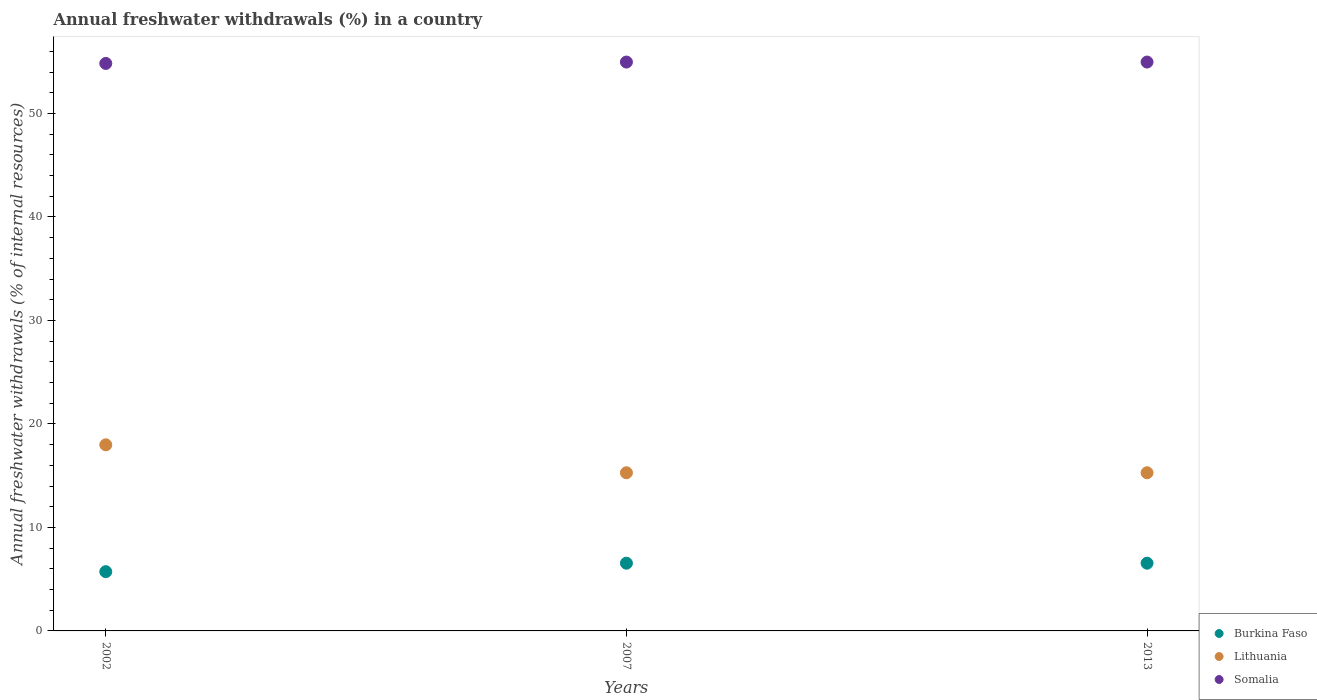Is the number of dotlines equal to the number of legend labels?
Offer a very short reply. Yes. What is the percentage of annual freshwater withdrawals in Lithuania in 2013?
Offer a very short reply. 15.28. Across all years, what is the maximum percentage of annual freshwater withdrawals in Burkina Faso?
Your response must be concise. 6.54. Across all years, what is the minimum percentage of annual freshwater withdrawals in Lithuania?
Your response must be concise. 15.28. In which year was the percentage of annual freshwater withdrawals in Somalia minimum?
Provide a succinct answer. 2002. What is the total percentage of annual freshwater withdrawals in Burkina Faso in the graph?
Keep it short and to the point. 18.81. What is the difference between the percentage of annual freshwater withdrawals in Burkina Faso in 2002 and that in 2007?
Provide a succinct answer. -0.82. What is the difference between the percentage of annual freshwater withdrawals in Burkina Faso in 2002 and the percentage of annual freshwater withdrawals in Somalia in 2007?
Give a very brief answer. -49.24. What is the average percentage of annual freshwater withdrawals in Somalia per year?
Provide a succinct answer. 54.92. In the year 2007, what is the difference between the percentage of annual freshwater withdrawals in Burkina Faso and percentage of annual freshwater withdrawals in Lithuania?
Provide a short and direct response. -8.74. What is the ratio of the percentage of annual freshwater withdrawals in Burkina Faso in 2002 to that in 2013?
Your answer should be very brief. 0.87. Is the difference between the percentage of annual freshwater withdrawals in Burkina Faso in 2007 and 2013 greater than the difference between the percentage of annual freshwater withdrawals in Lithuania in 2007 and 2013?
Provide a short and direct response. No. What is the difference between the highest and the second highest percentage of annual freshwater withdrawals in Lithuania?
Provide a succinct answer. 2.7. What is the difference between the highest and the lowest percentage of annual freshwater withdrawals in Burkina Faso?
Your response must be concise. 0.82. Is it the case that in every year, the sum of the percentage of annual freshwater withdrawals in Somalia and percentage of annual freshwater withdrawals in Burkina Faso  is greater than the percentage of annual freshwater withdrawals in Lithuania?
Keep it short and to the point. Yes. Does the percentage of annual freshwater withdrawals in Lithuania monotonically increase over the years?
Your response must be concise. No. Is the percentage of annual freshwater withdrawals in Burkina Faso strictly less than the percentage of annual freshwater withdrawals in Somalia over the years?
Your answer should be very brief. Yes. Does the graph contain grids?
Give a very brief answer. No. How many legend labels are there?
Your answer should be very brief. 3. What is the title of the graph?
Ensure brevity in your answer.  Annual freshwater withdrawals (%) in a country. Does "Cayman Islands" appear as one of the legend labels in the graph?
Offer a very short reply. No. What is the label or title of the Y-axis?
Keep it short and to the point. Annual freshwater withdrawals (% of internal resources). What is the Annual freshwater withdrawals (% of internal resources) of Burkina Faso in 2002?
Give a very brief answer. 5.73. What is the Annual freshwater withdrawals (% of internal resources) in Lithuania in 2002?
Your answer should be very brief. 17.98. What is the Annual freshwater withdrawals (% of internal resources) of Somalia in 2002?
Your response must be concise. 54.83. What is the Annual freshwater withdrawals (% of internal resources) in Burkina Faso in 2007?
Provide a succinct answer. 6.54. What is the Annual freshwater withdrawals (% of internal resources) in Lithuania in 2007?
Make the answer very short. 15.28. What is the Annual freshwater withdrawals (% of internal resources) of Somalia in 2007?
Make the answer very short. 54.97. What is the Annual freshwater withdrawals (% of internal resources) in Burkina Faso in 2013?
Offer a very short reply. 6.54. What is the Annual freshwater withdrawals (% of internal resources) of Lithuania in 2013?
Make the answer very short. 15.28. What is the Annual freshwater withdrawals (% of internal resources) of Somalia in 2013?
Your answer should be compact. 54.97. Across all years, what is the maximum Annual freshwater withdrawals (% of internal resources) in Burkina Faso?
Your response must be concise. 6.54. Across all years, what is the maximum Annual freshwater withdrawals (% of internal resources) of Lithuania?
Your response must be concise. 17.98. Across all years, what is the maximum Annual freshwater withdrawals (% of internal resources) of Somalia?
Make the answer very short. 54.97. Across all years, what is the minimum Annual freshwater withdrawals (% of internal resources) in Burkina Faso?
Give a very brief answer. 5.73. Across all years, what is the minimum Annual freshwater withdrawals (% of internal resources) in Lithuania?
Ensure brevity in your answer.  15.28. Across all years, what is the minimum Annual freshwater withdrawals (% of internal resources) in Somalia?
Offer a terse response. 54.83. What is the total Annual freshwater withdrawals (% of internal resources) in Burkina Faso in the graph?
Give a very brief answer. 18.81. What is the total Annual freshwater withdrawals (% of internal resources) in Lithuania in the graph?
Offer a terse response. 48.55. What is the total Annual freshwater withdrawals (% of internal resources) of Somalia in the graph?
Make the answer very short. 164.77. What is the difference between the Annual freshwater withdrawals (% of internal resources) of Burkina Faso in 2002 and that in 2007?
Offer a terse response. -0.82. What is the difference between the Annual freshwater withdrawals (% of internal resources) of Lithuania in 2002 and that in 2007?
Your answer should be very brief. 2.7. What is the difference between the Annual freshwater withdrawals (% of internal resources) in Somalia in 2002 and that in 2007?
Offer a terse response. -0.13. What is the difference between the Annual freshwater withdrawals (% of internal resources) of Burkina Faso in 2002 and that in 2013?
Offer a very short reply. -0.82. What is the difference between the Annual freshwater withdrawals (% of internal resources) in Lithuania in 2002 and that in 2013?
Ensure brevity in your answer.  2.7. What is the difference between the Annual freshwater withdrawals (% of internal resources) in Somalia in 2002 and that in 2013?
Make the answer very short. -0.13. What is the difference between the Annual freshwater withdrawals (% of internal resources) in Burkina Faso in 2007 and that in 2013?
Provide a succinct answer. 0. What is the difference between the Annual freshwater withdrawals (% of internal resources) of Burkina Faso in 2002 and the Annual freshwater withdrawals (% of internal resources) of Lithuania in 2007?
Ensure brevity in your answer.  -9.56. What is the difference between the Annual freshwater withdrawals (% of internal resources) of Burkina Faso in 2002 and the Annual freshwater withdrawals (% of internal resources) of Somalia in 2007?
Offer a very short reply. -49.24. What is the difference between the Annual freshwater withdrawals (% of internal resources) of Lithuania in 2002 and the Annual freshwater withdrawals (% of internal resources) of Somalia in 2007?
Keep it short and to the point. -36.98. What is the difference between the Annual freshwater withdrawals (% of internal resources) in Burkina Faso in 2002 and the Annual freshwater withdrawals (% of internal resources) in Lithuania in 2013?
Your answer should be compact. -9.56. What is the difference between the Annual freshwater withdrawals (% of internal resources) in Burkina Faso in 2002 and the Annual freshwater withdrawals (% of internal resources) in Somalia in 2013?
Your answer should be very brief. -49.24. What is the difference between the Annual freshwater withdrawals (% of internal resources) of Lithuania in 2002 and the Annual freshwater withdrawals (% of internal resources) of Somalia in 2013?
Keep it short and to the point. -36.98. What is the difference between the Annual freshwater withdrawals (% of internal resources) of Burkina Faso in 2007 and the Annual freshwater withdrawals (% of internal resources) of Lithuania in 2013?
Ensure brevity in your answer.  -8.74. What is the difference between the Annual freshwater withdrawals (% of internal resources) in Burkina Faso in 2007 and the Annual freshwater withdrawals (% of internal resources) in Somalia in 2013?
Provide a short and direct response. -48.42. What is the difference between the Annual freshwater withdrawals (% of internal resources) in Lithuania in 2007 and the Annual freshwater withdrawals (% of internal resources) in Somalia in 2013?
Provide a succinct answer. -39.68. What is the average Annual freshwater withdrawals (% of internal resources) of Burkina Faso per year?
Your answer should be very brief. 6.27. What is the average Annual freshwater withdrawals (% of internal resources) of Lithuania per year?
Make the answer very short. 16.18. What is the average Annual freshwater withdrawals (% of internal resources) of Somalia per year?
Give a very brief answer. 54.92. In the year 2002, what is the difference between the Annual freshwater withdrawals (% of internal resources) of Burkina Faso and Annual freshwater withdrawals (% of internal resources) of Lithuania?
Your answer should be very brief. -12.26. In the year 2002, what is the difference between the Annual freshwater withdrawals (% of internal resources) in Burkina Faso and Annual freshwater withdrawals (% of internal resources) in Somalia?
Provide a succinct answer. -49.11. In the year 2002, what is the difference between the Annual freshwater withdrawals (% of internal resources) in Lithuania and Annual freshwater withdrawals (% of internal resources) in Somalia?
Make the answer very short. -36.85. In the year 2007, what is the difference between the Annual freshwater withdrawals (% of internal resources) in Burkina Faso and Annual freshwater withdrawals (% of internal resources) in Lithuania?
Your answer should be very brief. -8.74. In the year 2007, what is the difference between the Annual freshwater withdrawals (% of internal resources) of Burkina Faso and Annual freshwater withdrawals (% of internal resources) of Somalia?
Ensure brevity in your answer.  -48.42. In the year 2007, what is the difference between the Annual freshwater withdrawals (% of internal resources) of Lithuania and Annual freshwater withdrawals (% of internal resources) of Somalia?
Your response must be concise. -39.68. In the year 2013, what is the difference between the Annual freshwater withdrawals (% of internal resources) of Burkina Faso and Annual freshwater withdrawals (% of internal resources) of Lithuania?
Offer a very short reply. -8.74. In the year 2013, what is the difference between the Annual freshwater withdrawals (% of internal resources) in Burkina Faso and Annual freshwater withdrawals (% of internal resources) in Somalia?
Make the answer very short. -48.42. In the year 2013, what is the difference between the Annual freshwater withdrawals (% of internal resources) of Lithuania and Annual freshwater withdrawals (% of internal resources) of Somalia?
Give a very brief answer. -39.68. What is the ratio of the Annual freshwater withdrawals (% of internal resources) of Burkina Faso in 2002 to that in 2007?
Give a very brief answer. 0.87. What is the ratio of the Annual freshwater withdrawals (% of internal resources) of Lithuania in 2002 to that in 2007?
Offer a terse response. 1.18. What is the ratio of the Annual freshwater withdrawals (% of internal resources) of Burkina Faso in 2002 to that in 2013?
Provide a succinct answer. 0.87. What is the ratio of the Annual freshwater withdrawals (% of internal resources) of Lithuania in 2002 to that in 2013?
Keep it short and to the point. 1.18. What is the ratio of the Annual freshwater withdrawals (% of internal resources) in Burkina Faso in 2007 to that in 2013?
Offer a very short reply. 1. What is the ratio of the Annual freshwater withdrawals (% of internal resources) of Lithuania in 2007 to that in 2013?
Provide a succinct answer. 1. What is the difference between the highest and the second highest Annual freshwater withdrawals (% of internal resources) of Burkina Faso?
Give a very brief answer. 0. What is the difference between the highest and the second highest Annual freshwater withdrawals (% of internal resources) in Lithuania?
Make the answer very short. 2.7. What is the difference between the highest and the lowest Annual freshwater withdrawals (% of internal resources) in Burkina Faso?
Provide a succinct answer. 0.82. What is the difference between the highest and the lowest Annual freshwater withdrawals (% of internal resources) in Lithuania?
Your response must be concise. 2.7. What is the difference between the highest and the lowest Annual freshwater withdrawals (% of internal resources) in Somalia?
Your answer should be compact. 0.13. 